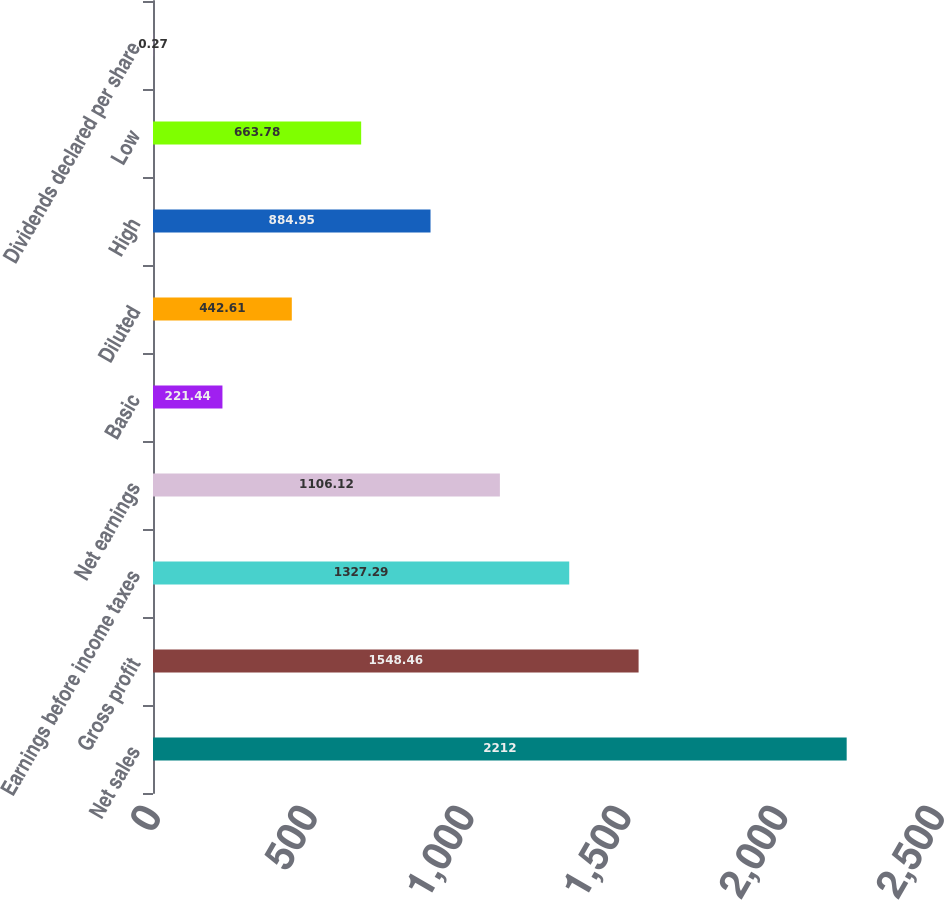Convert chart. <chart><loc_0><loc_0><loc_500><loc_500><bar_chart><fcel>Net sales<fcel>Gross profit<fcel>Earnings before income taxes<fcel>Net earnings<fcel>Basic<fcel>Diluted<fcel>High<fcel>Low<fcel>Dividends declared per share<nl><fcel>2212<fcel>1548.46<fcel>1327.29<fcel>1106.12<fcel>221.44<fcel>442.61<fcel>884.95<fcel>663.78<fcel>0.27<nl></chart> 